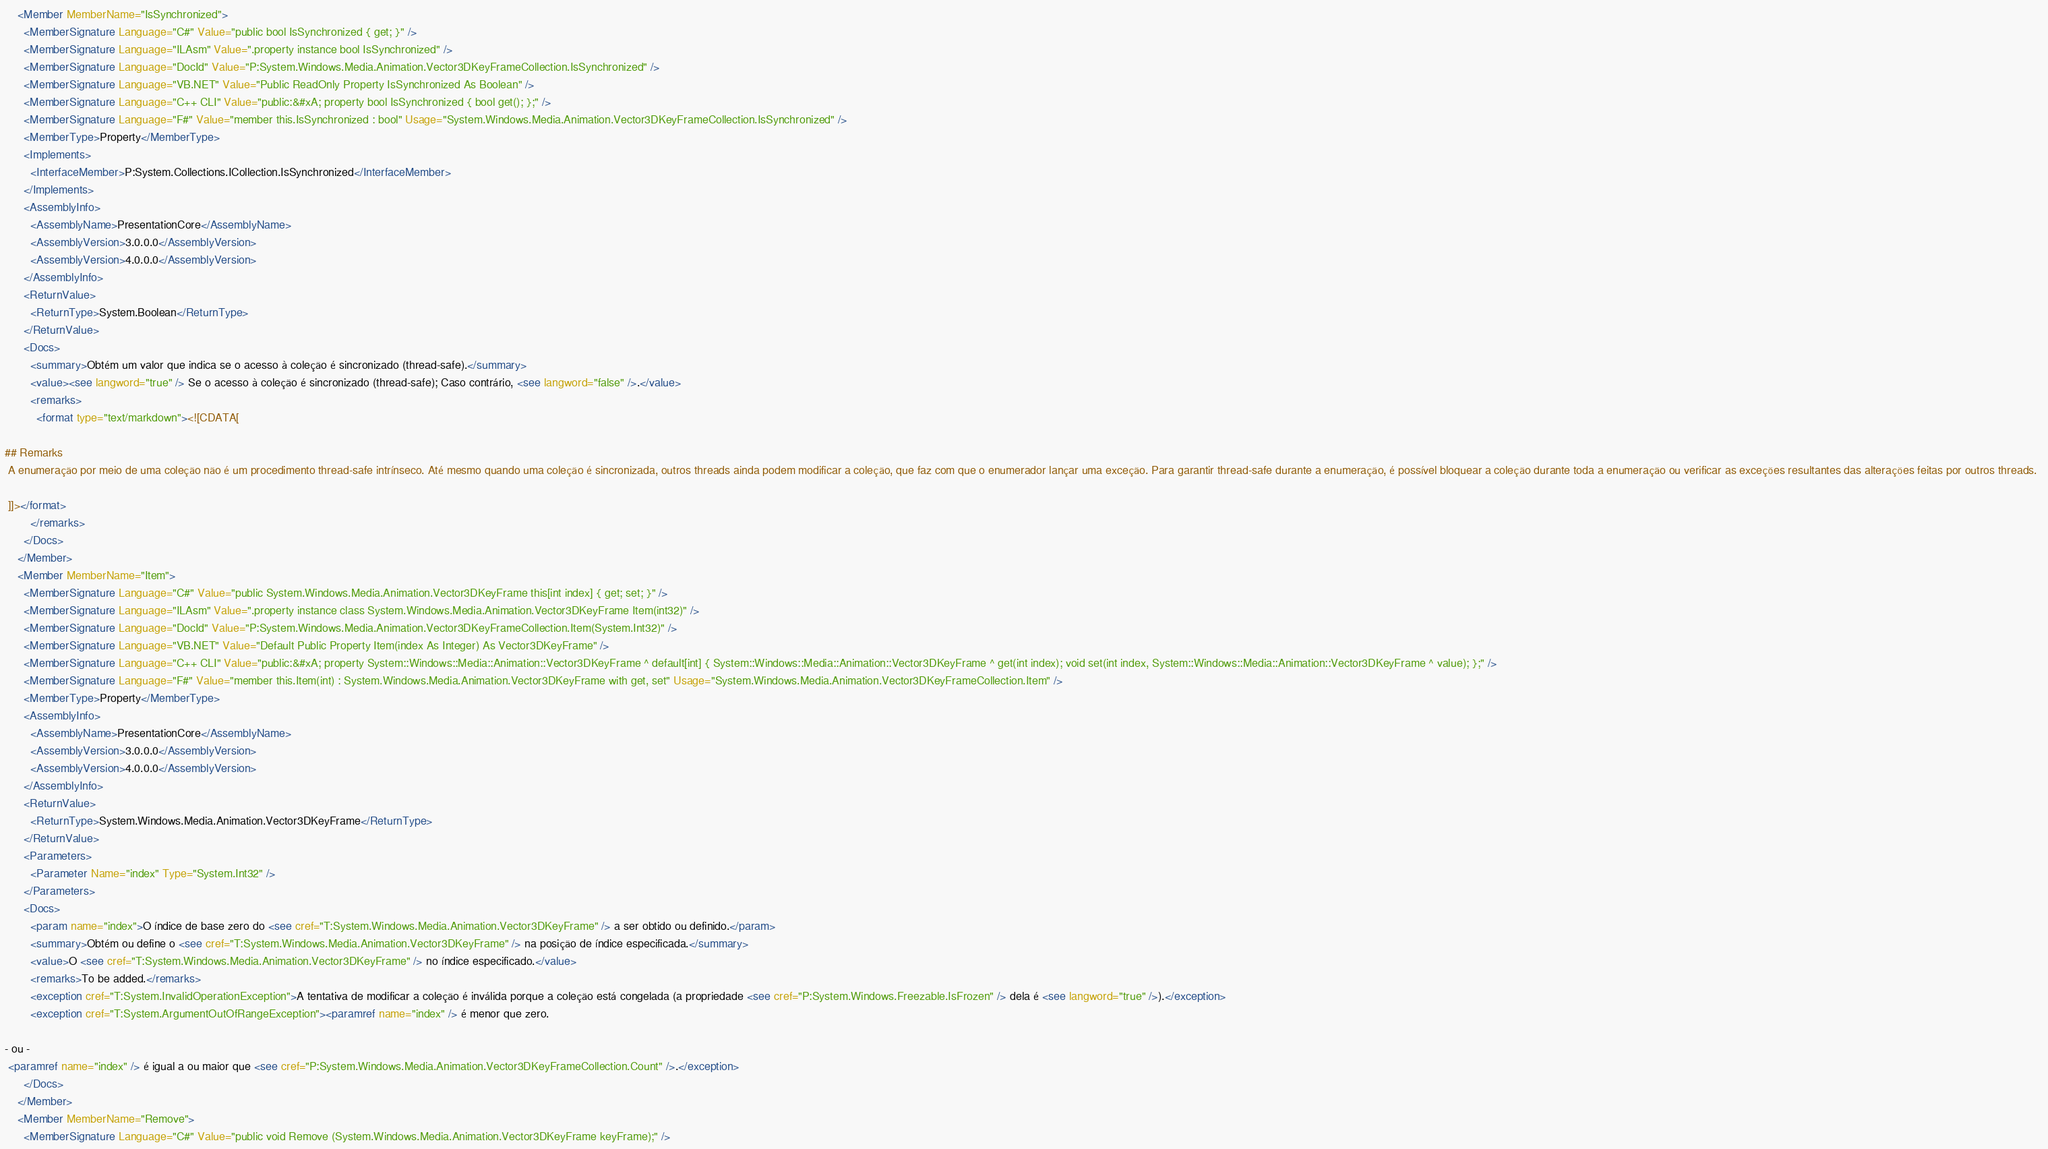Convert code to text. <code><loc_0><loc_0><loc_500><loc_500><_XML_>    <Member MemberName="IsSynchronized">
      <MemberSignature Language="C#" Value="public bool IsSynchronized { get; }" />
      <MemberSignature Language="ILAsm" Value=".property instance bool IsSynchronized" />
      <MemberSignature Language="DocId" Value="P:System.Windows.Media.Animation.Vector3DKeyFrameCollection.IsSynchronized" />
      <MemberSignature Language="VB.NET" Value="Public ReadOnly Property IsSynchronized As Boolean" />
      <MemberSignature Language="C++ CLI" Value="public:&#xA; property bool IsSynchronized { bool get(); };" />
      <MemberSignature Language="F#" Value="member this.IsSynchronized : bool" Usage="System.Windows.Media.Animation.Vector3DKeyFrameCollection.IsSynchronized" />
      <MemberType>Property</MemberType>
      <Implements>
        <InterfaceMember>P:System.Collections.ICollection.IsSynchronized</InterfaceMember>
      </Implements>
      <AssemblyInfo>
        <AssemblyName>PresentationCore</AssemblyName>
        <AssemblyVersion>3.0.0.0</AssemblyVersion>
        <AssemblyVersion>4.0.0.0</AssemblyVersion>
      </AssemblyInfo>
      <ReturnValue>
        <ReturnType>System.Boolean</ReturnType>
      </ReturnValue>
      <Docs>
        <summary>Obtém um valor que indica se o acesso à coleção é sincronizado (thread-safe).</summary>
        <value><see langword="true" /> Se o acesso à coleção é sincronizado (thread-safe); Caso contrário, <see langword="false" />.</value>
        <remarks>
          <format type="text/markdown"><![CDATA[  
  
## Remarks  
 A enumeração por meio de uma coleção não é um procedimento thread-safe intrínseco. Até mesmo quando uma coleção é sincronizada, outros threads ainda podem modificar a coleção, que faz com que o enumerador lançar uma exceção. Para garantir thread-safe durante a enumeração, é possível bloquear a coleção durante toda a enumeração ou verificar as exceções resultantes das alterações feitas por outros threads.  
  
 ]]></format>
        </remarks>
      </Docs>
    </Member>
    <Member MemberName="Item">
      <MemberSignature Language="C#" Value="public System.Windows.Media.Animation.Vector3DKeyFrame this[int index] { get; set; }" />
      <MemberSignature Language="ILAsm" Value=".property instance class System.Windows.Media.Animation.Vector3DKeyFrame Item(int32)" />
      <MemberSignature Language="DocId" Value="P:System.Windows.Media.Animation.Vector3DKeyFrameCollection.Item(System.Int32)" />
      <MemberSignature Language="VB.NET" Value="Default Public Property Item(index As Integer) As Vector3DKeyFrame" />
      <MemberSignature Language="C++ CLI" Value="public:&#xA; property System::Windows::Media::Animation::Vector3DKeyFrame ^ default[int] { System::Windows::Media::Animation::Vector3DKeyFrame ^ get(int index); void set(int index, System::Windows::Media::Animation::Vector3DKeyFrame ^ value); };" />
      <MemberSignature Language="F#" Value="member this.Item(int) : System.Windows.Media.Animation.Vector3DKeyFrame with get, set" Usage="System.Windows.Media.Animation.Vector3DKeyFrameCollection.Item" />
      <MemberType>Property</MemberType>
      <AssemblyInfo>
        <AssemblyName>PresentationCore</AssemblyName>
        <AssemblyVersion>3.0.0.0</AssemblyVersion>
        <AssemblyVersion>4.0.0.0</AssemblyVersion>
      </AssemblyInfo>
      <ReturnValue>
        <ReturnType>System.Windows.Media.Animation.Vector3DKeyFrame</ReturnType>
      </ReturnValue>
      <Parameters>
        <Parameter Name="index" Type="System.Int32" />
      </Parameters>
      <Docs>
        <param name="index">O índice de base zero do <see cref="T:System.Windows.Media.Animation.Vector3DKeyFrame" /> a ser obtido ou definido.</param>
        <summary>Obtém ou define o <see cref="T:System.Windows.Media.Animation.Vector3DKeyFrame" /> na posição de índice especificada.</summary>
        <value>O <see cref="T:System.Windows.Media.Animation.Vector3DKeyFrame" /> no índice especificado.</value>
        <remarks>To be added.</remarks>
        <exception cref="T:System.InvalidOperationException">A tentativa de modificar a coleção é inválida porque a coleção está congelada (a propriedade <see cref="P:System.Windows.Freezable.IsFrozen" /> dela é <see langword="true" />).</exception>
        <exception cref="T:System.ArgumentOutOfRangeException"><paramref name="index" /> é menor que zero.  
  
- ou - 
 <paramref name="index" /> é igual a ou maior que <see cref="P:System.Windows.Media.Animation.Vector3DKeyFrameCollection.Count" />.</exception>
      </Docs>
    </Member>
    <Member MemberName="Remove">
      <MemberSignature Language="C#" Value="public void Remove (System.Windows.Media.Animation.Vector3DKeyFrame keyFrame);" /></code> 